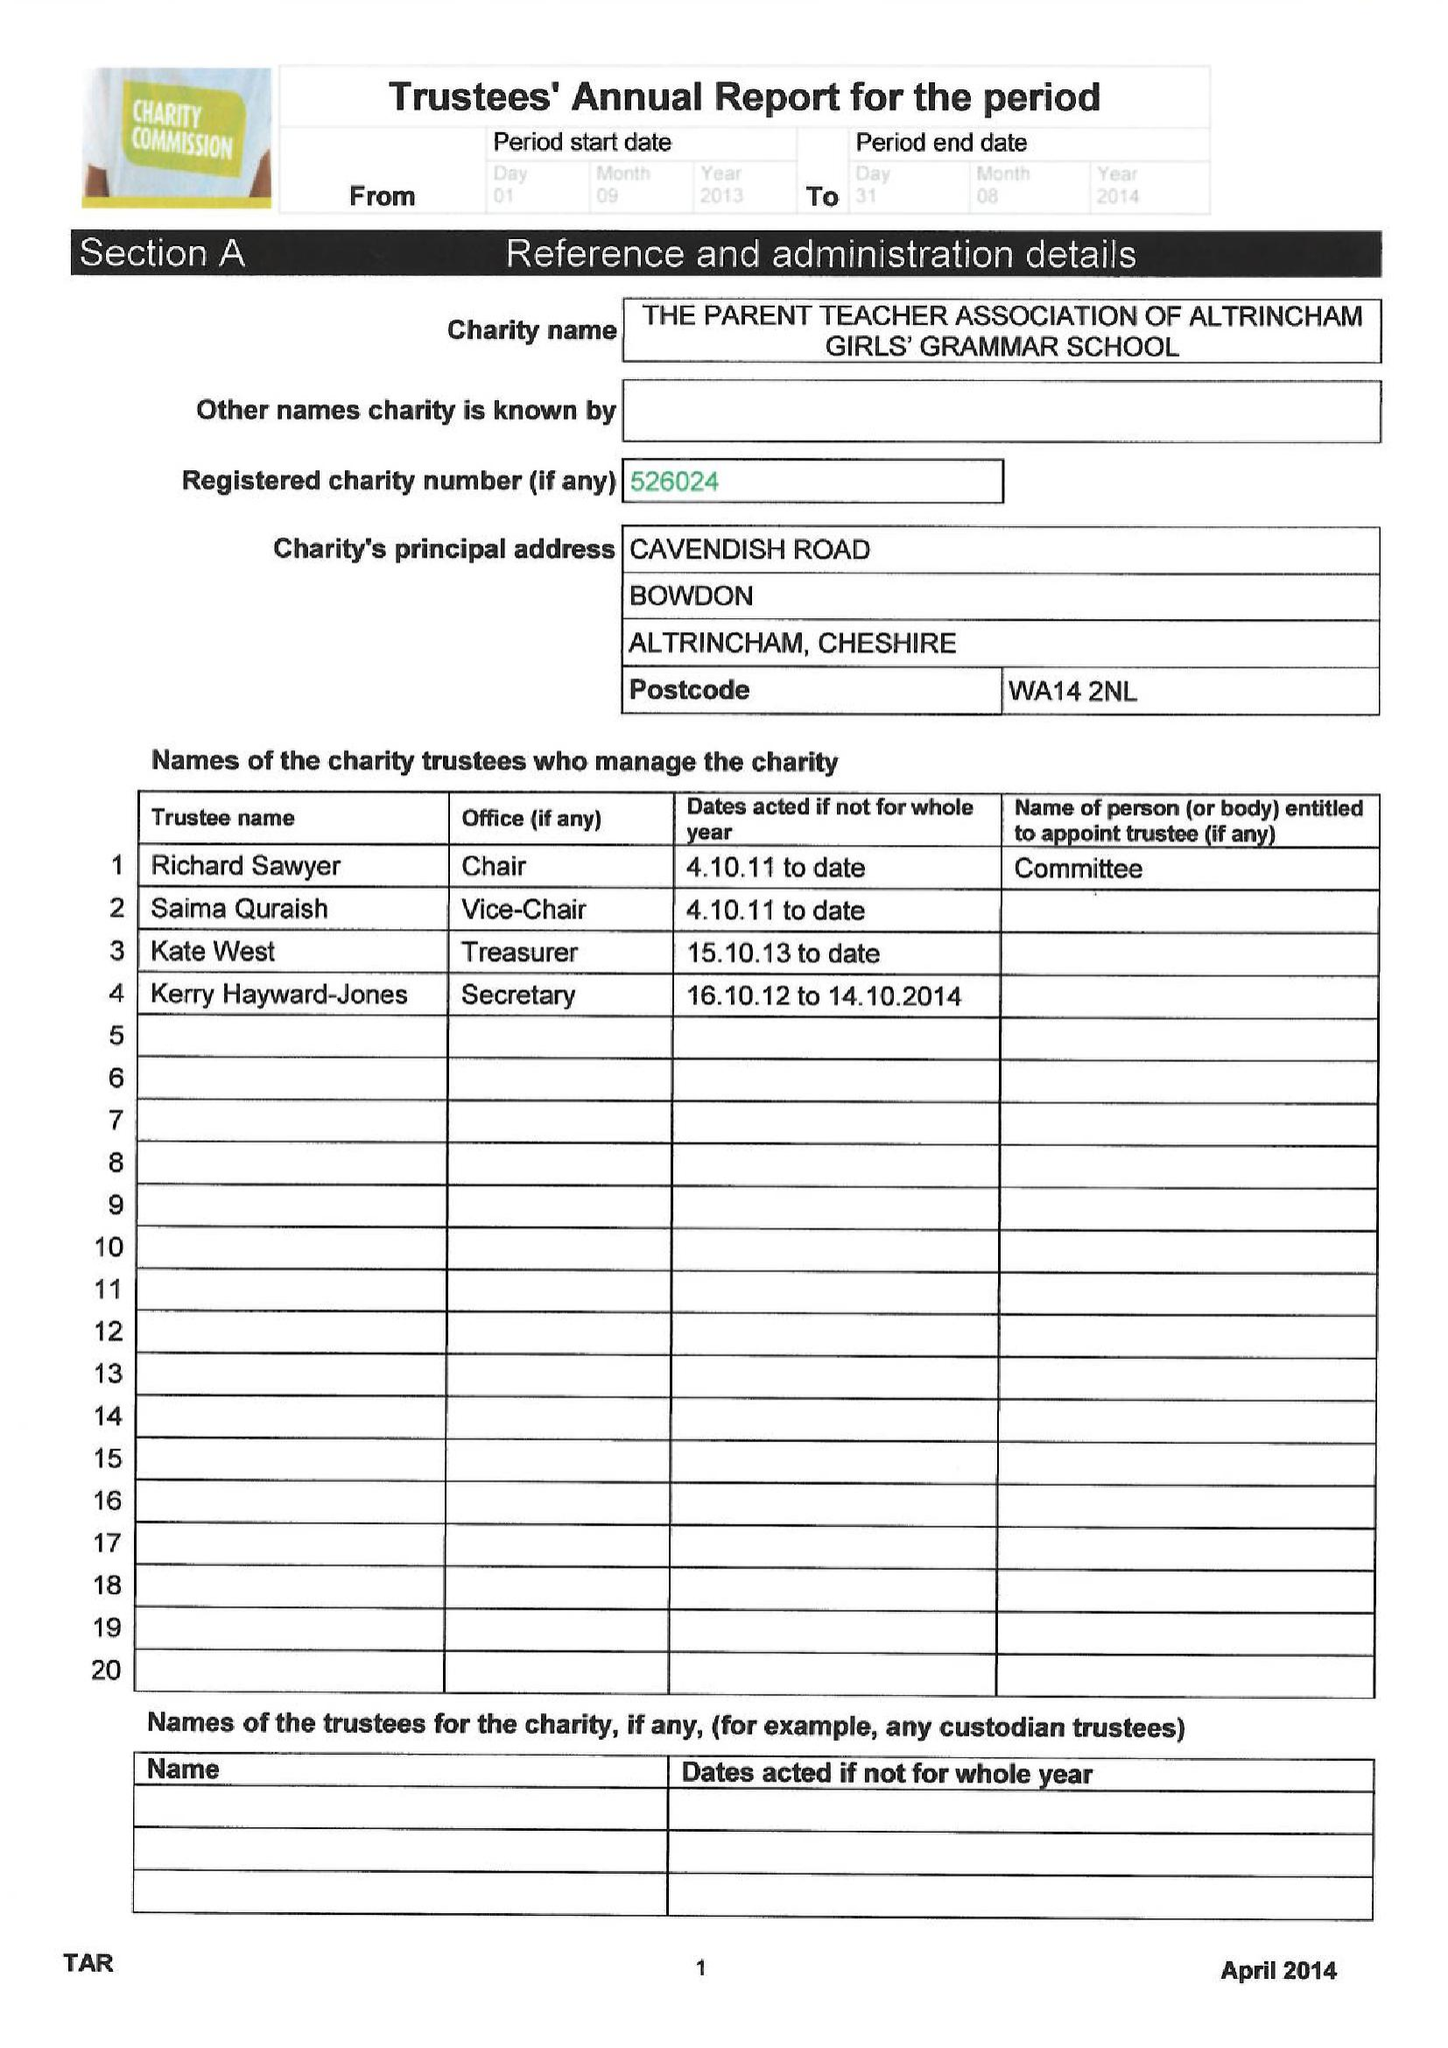What is the value for the charity_number?
Answer the question using a single word or phrase. 526024 